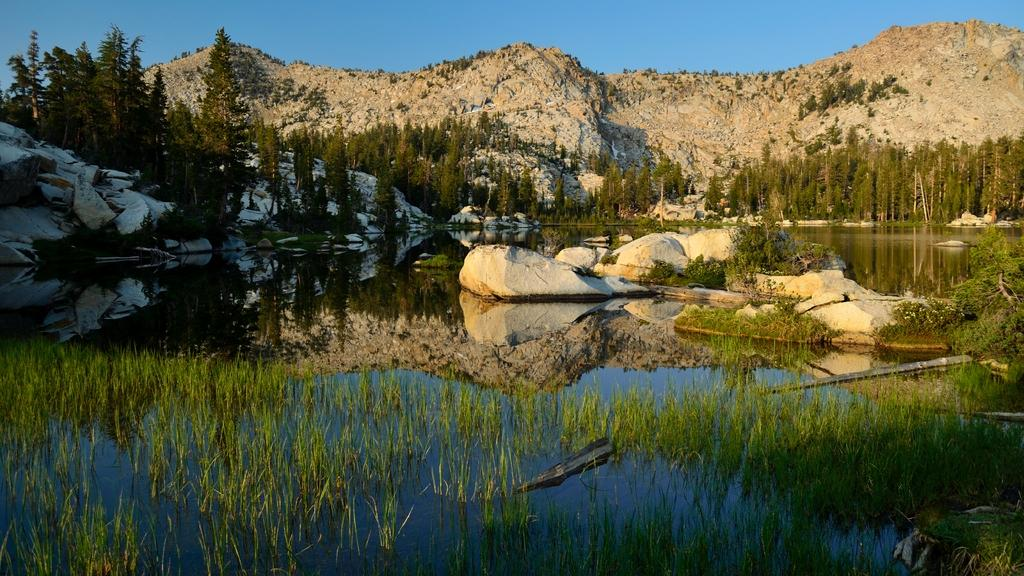What is unusual about the grass in the image? The grass is in the water. What can be seen in the water in the background? There are rocks in the water in the background. What is located near the rocks? There are plants near the rocks. What is visible on the hill in the background? There are trees on a hill in the background. What color is the sky in the image? The sky is blue. Can you see a pen floating on the water in the image? There is no pen visible in the image; it only features grass, rocks, plants, trees, and a blue sky. 